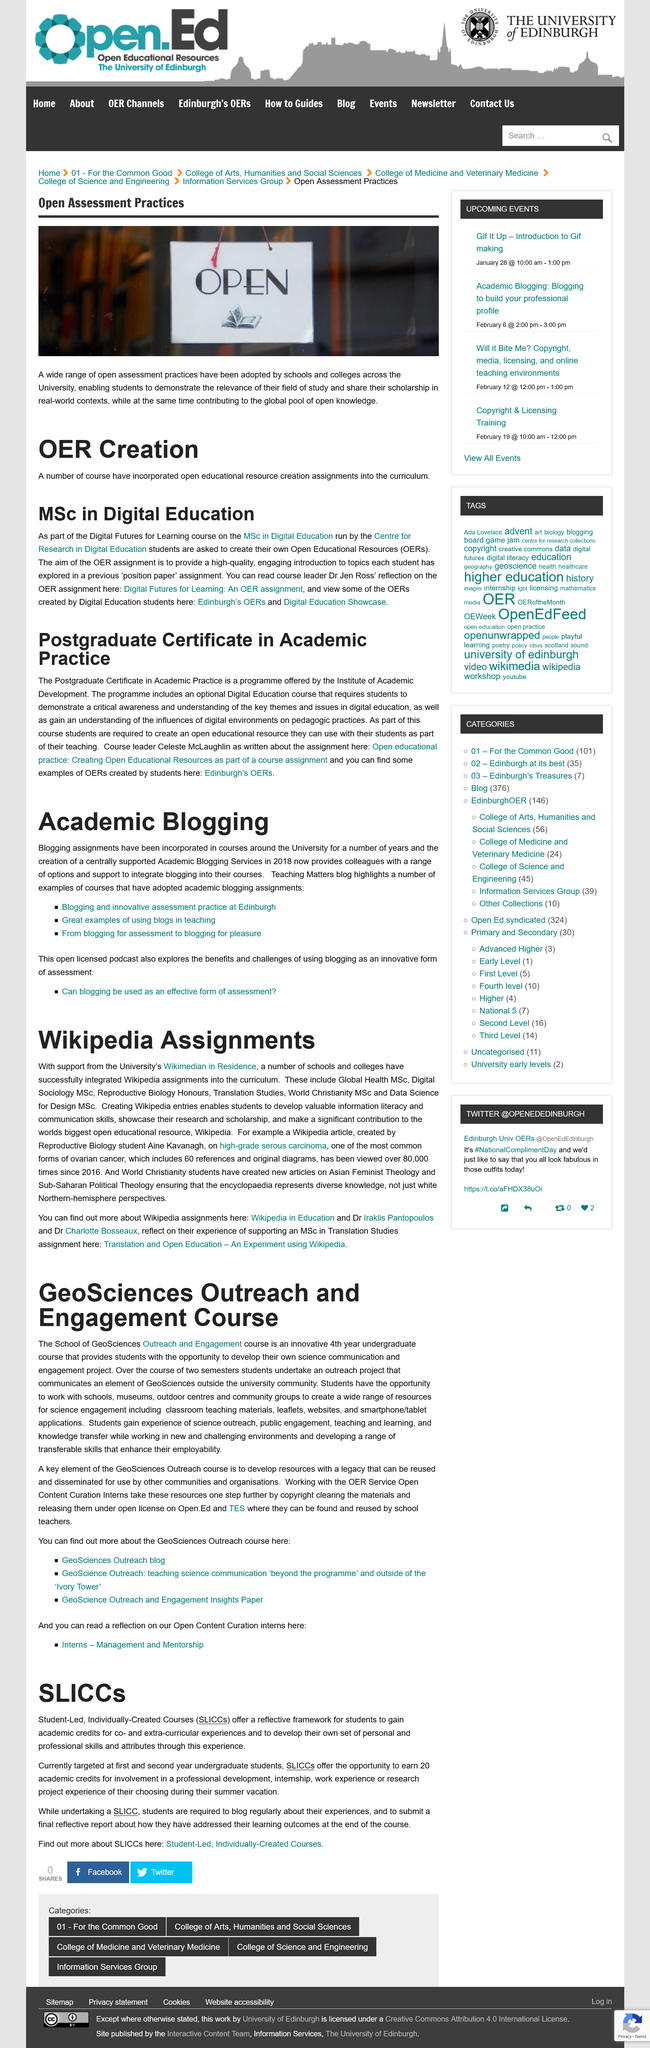Mention a couple of crucial points in this snapshot. The courses that offer a reflective framework for students typically offer 20 credits. The Geoscience course at the School of Geoscience provides students with the opportunity to develop their own science and engagement project, allowing them to hone their skills in communication and outreach. The MSc in Digital Education is run by the Centre for Research in Digital Education. Wikipedia assignments can be found out at the Wikipedia in Education link. The Outreach and Engagement course is available to students in their fourth year of undergraduate studies. 